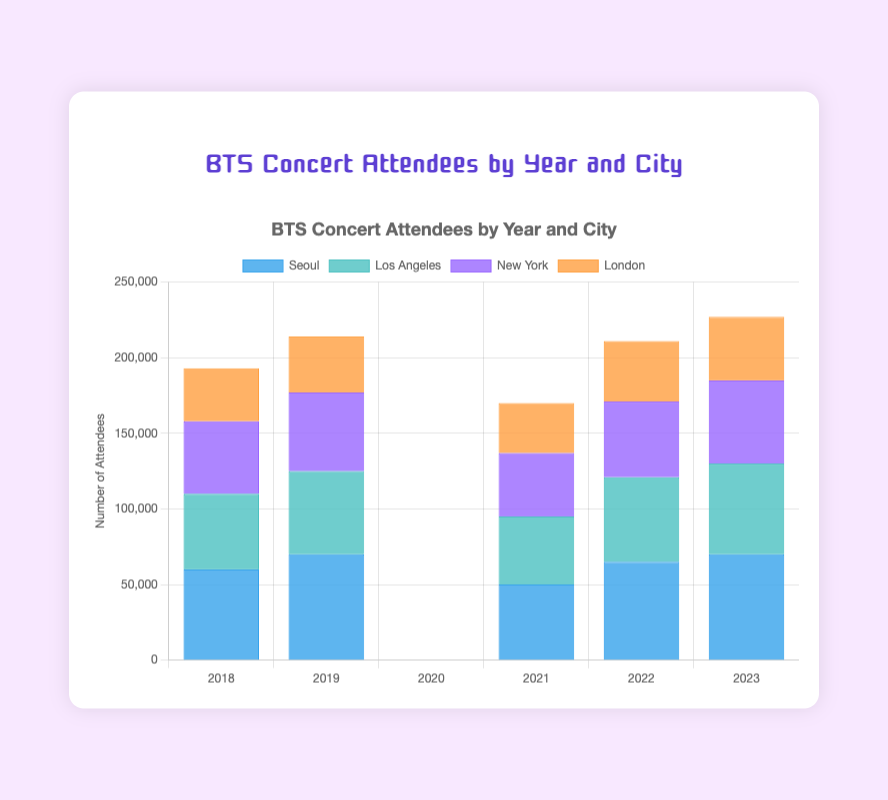Which city had the highest number of concert attendees in 2019? Look at the bars representing the year 2019. Identify the tallest bar and check its corresponding city. Seoul has the tallest bar with 70,000 attendees.
Answer: Seoul What is the total number of BTS concert attendees in Seoul for the given years? Sum the number of attendees in Seoul for each year: 60,000 (2018) + 70,000 (2019) + 0 (2020) + 50,000 (2021) + 65,000 (2022) + 70,000 (2023). The total is 315,000.
Answer: 315,000 Which was the year with the lowest total number of attendees across all cities, excluding 2020? Exclude the year 2020, then add the attendees for each city for the remaining years. The year with the smallest sum is the lowest. 2021: 50,000 (Seoul) + 45,000 (Los Angeles) + 42,000 (New York) + 33,000 (London) = 170,000 which is the lowest.
Answer: 2021 How did the number of attendees change in Seoul from 2018 to 2023? Compare the height of the bars for Seoul over the years from 2018 to 2023. Attendees increased from 60,000 (2018) to 70,000 (2023).
Answer: Increased What is the average number of attendees in Los Angeles from 2018 to 2023? Add the number of attendees for each year in Los Angeles and divide by the number of years: (50,000 + 55,000 + 0 + 45,000 + 56,000 + 60,000) / 6 = 44,333.33.
Answer: 44,333.33 Which city had the biggest drop in attendees from 2019 to 2021? Compare the numbers of attendees for each city from 2019 and 2021. Calculate the drops: Seoul (70,000 to 50,000), Los Angeles (55,000 to 45,000), New York (52,000 to 42,000), London (37,000 to 33,000). Seoul had the largest drop of 20,000.
Answer: Seoul Which year had the same number of attendees for New York and London? Compare the bars for New York and London. Only in 2023 do both cities have 42,000 attendees each.
Answer: 2023 For which city did the number of attendees exceed 50,000 in 2022? Check the heights of the bars for the year 2022 and identify those for which the number of attendees exceeded 50,000. Seoul (65,000) and Los Angeles (56,000) meet this criterion.
Answer: Seoul, Los Angeles 